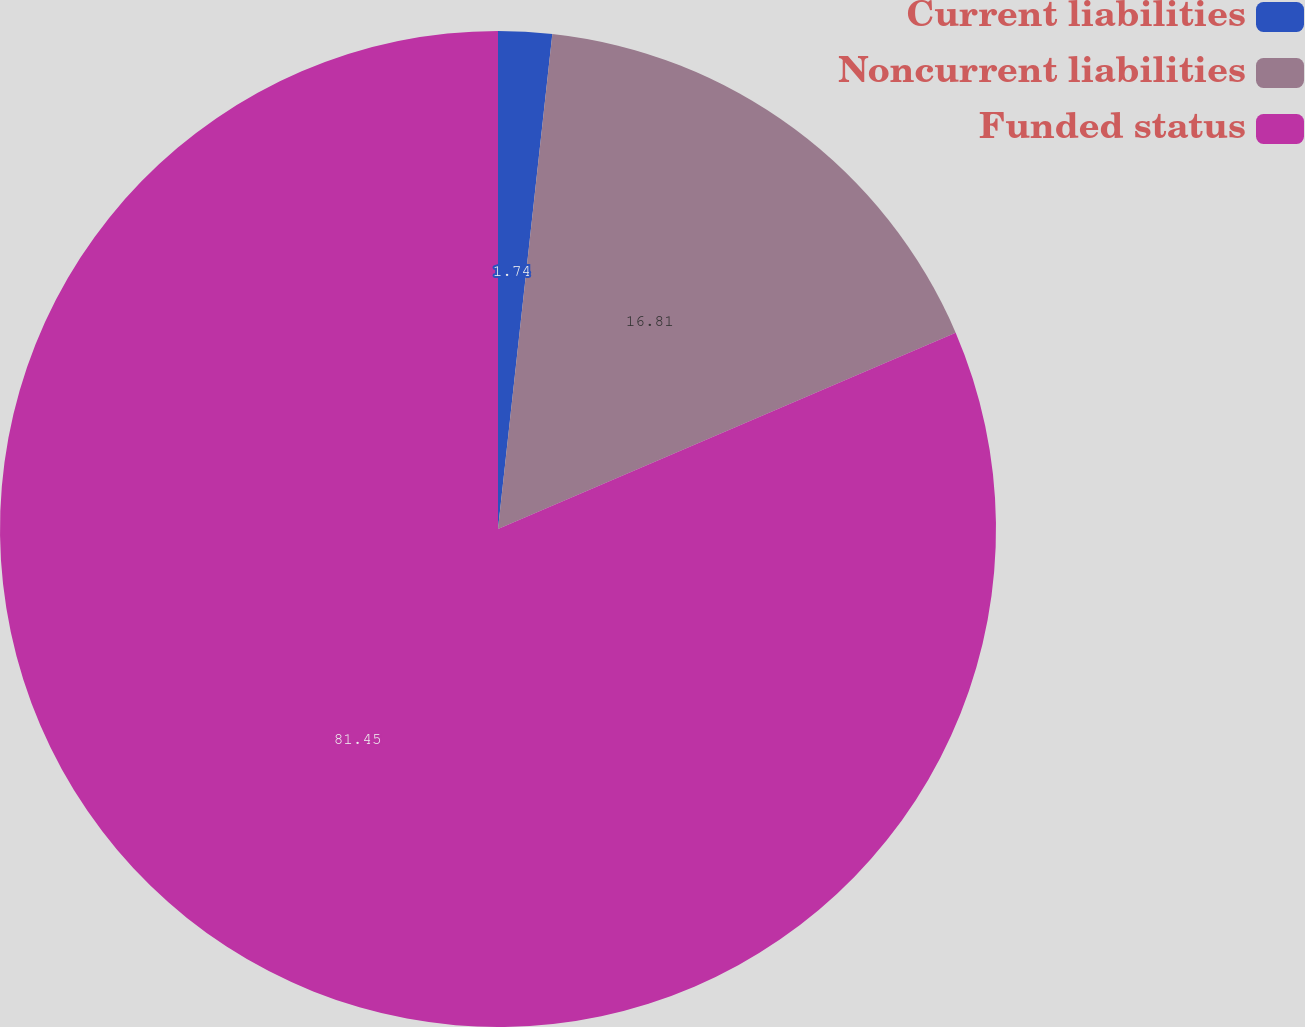<chart> <loc_0><loc_0><loc_500><loc_500><pie_chart><fcel>Current liabilities<fcel>Noncurrent liabilities<fcel>Funded status<nl><fcel>1.74%<fcel>16.81%<fcel>81.45%<nl></chart> 